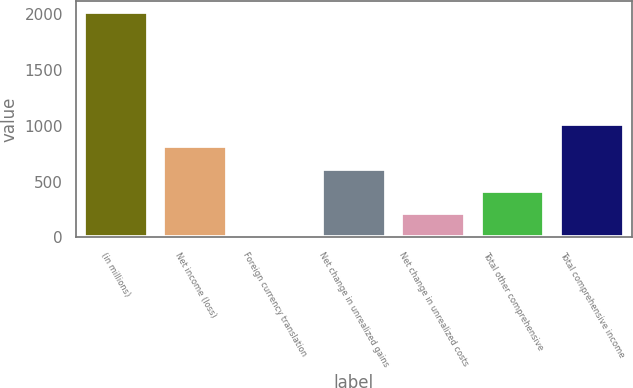<chart> <loc_0><loc_0><loc_500><loc_500><bar_chart><fcel>(in millions)<fcel>Net income (loss)<fcel>Foreign currency translation<fcel>Net change in unrealized gains<fcel>Net change in unrealized costs<fcel>Total other comprehensive<fcel>Total comprehensive income<nl><fcel>2015<fcel>815.6<fcel>16<fcel>615.7<fcel>215.9<fcel>415.8<fcel>1015.5<nl></chart> 